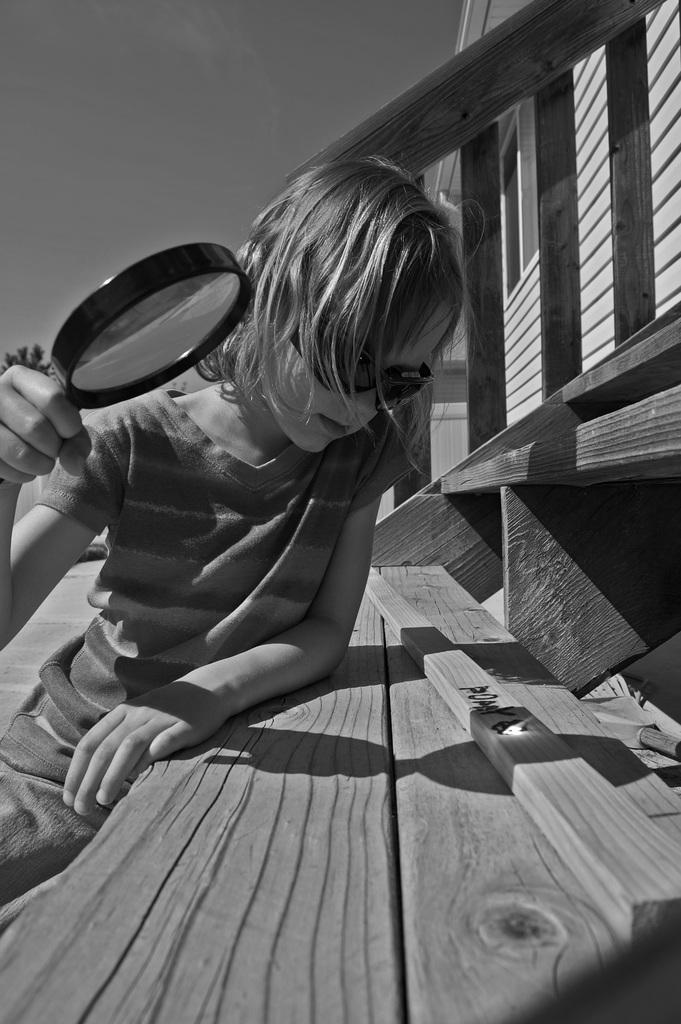Describe this image in one or two sentences. In the picture we can see a kid wearing black color goggles sitting on wooden stairs and holding magnifying glass in his hands, on right side of the picture there is wooden house. 